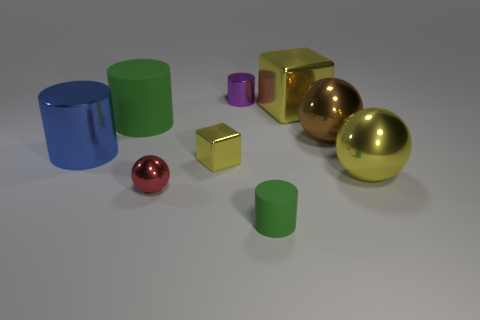What material is the green thing that is in front of the green cylinder behind the rubber cylinder that is in front of the large green matte cylinder?
Your response must be concise. Rubber. Do the large blue shiny thing and the large brown object have the same shape?
Provide a succinct answer. No. How many metallic things are either purple cylinders or yellow spheres?
Provide a succinct answer. 2. What number of big green matte things are there?
Offer a terse response. 1. There is a sphere that is the same size as the purple metallic cylinder; what is its color?
Make the answer very short. Red. Is the purple object the same size as the blue cylinder?
Provide a short and direct response. No. What is the shape of the large thing that is the same color as the tiny rubber cylinder?
Provide a short and direct response. Cylinder. Do the red ball and the metallic cylinder that is on the right side of the red thing have the same size?
Give a very brief answer. Yes. There is a metal thing that is behind the big green rubber object and to the right of the purple metallic cylinder; what color is it?
Your response must be concise. Yellow. Is the number of large blue things that are left of the large green rubber object greater than the number of large brown metal things right of the big brown metal ball?
Your response must be concise. Yes. 